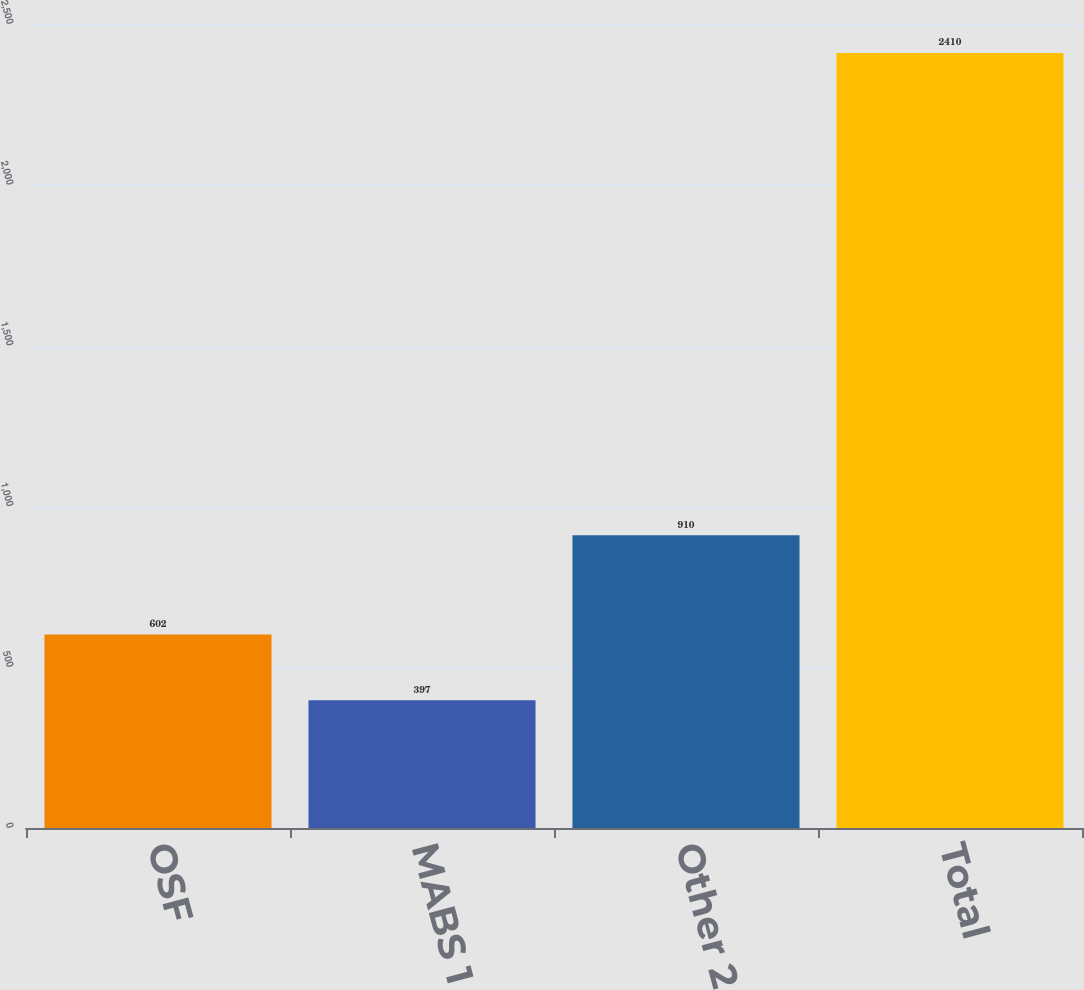Convert chart. <chart><loc_0><loc_0><loc_500><loc_500><bar_chart><fcel>OSF<fcel>MABS 1<fcel>Other 2<fcel>Total<nl><fcel>602<fcel>397<fcel>910<fcel>2410<nl></chart> 